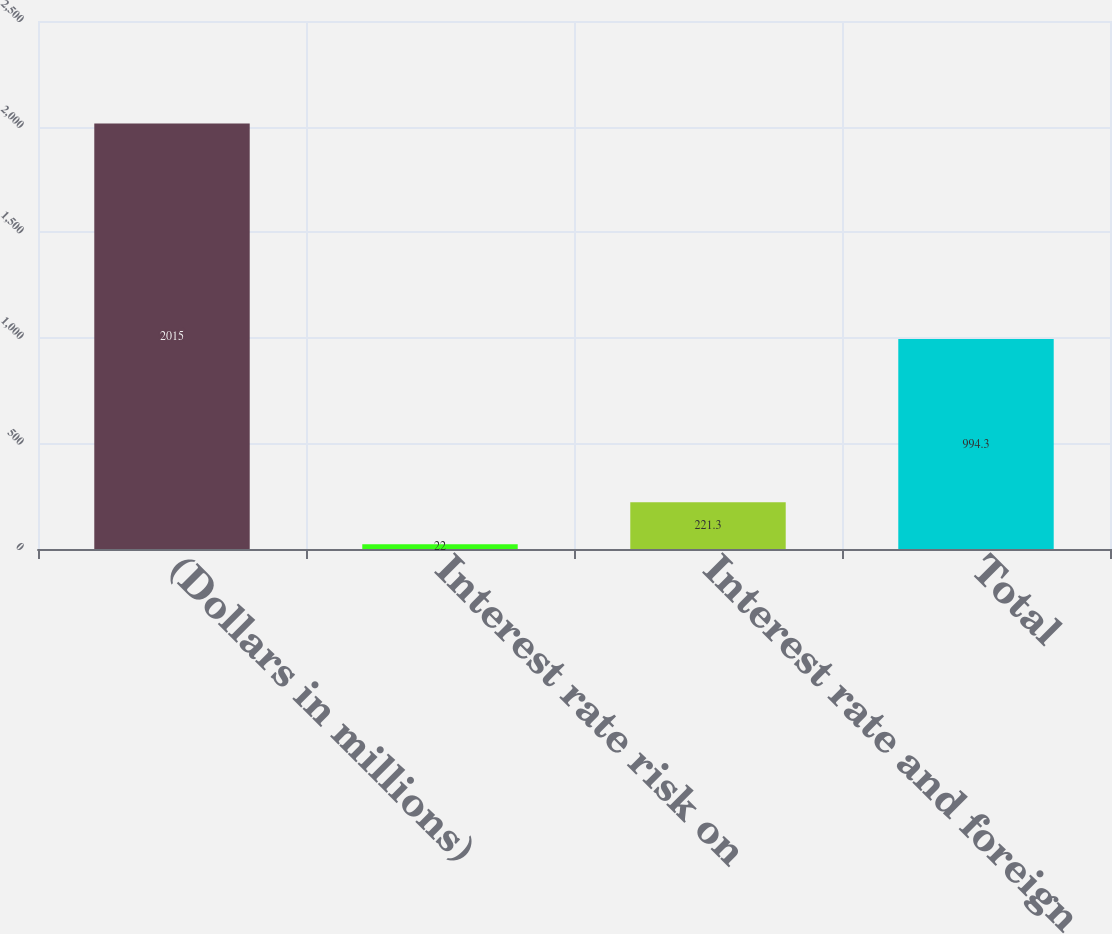Convert chart to OTSL. <chart><loc_0><loc_0><loc_500><loc_500><bar_chart><fcel>(Dollars in millions)<fcel>Interest rate risk on<fcel>Interest rate and foreign<fcel>Total<nl><fcel>2015<fcel>22<fcel>221.3<fcel>994.3<nl></chart> 